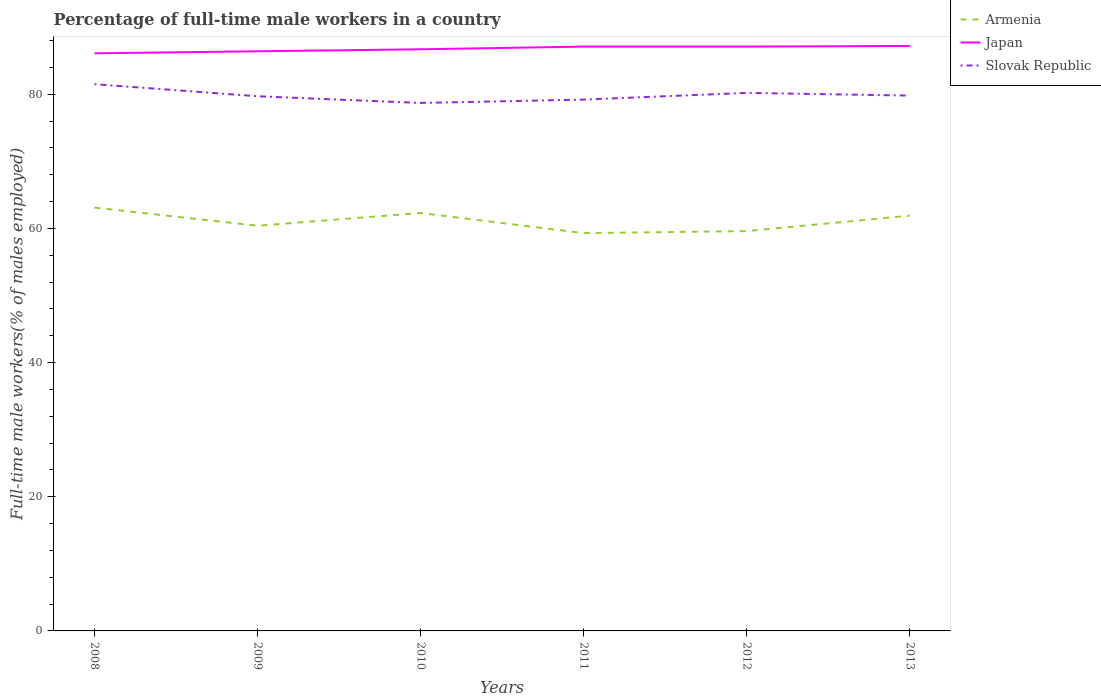Across all years, what is the maximum percentage of full-time male workers in Armenia?
Provide a succinct answer. 59.3. In which year was the percentage of full-time male workers in Slovak Republic maximum?
Give a very brief answer. 2010. What is the total percentage of full-time male workers in Japan in the graph?
Your answer should be very brief. -1.1. What is the difference between the highest and the second highest percentage of full-time male workers in Slovak Republic?
Your answer should be compact. 2.8. Is the percentage of full-time male workers in Japan strictly greater than the percentage of full-time male workers in Armenia over the years?
Provide a succinct answer. No. How many years are there in the graph?
Your answer should be very brief. 6. Where does the legend appear in the graph?
Give a very brief answer. Top right. What is the title of the graph?
Provide a short and direct response. Percentage of full-time male workers in a country. What is the label or title of the Y-axis?
Give a very brief answer. Full-time male workers(% of males employed). What is the Full-time male workers(% of males employed) in Armenia in 2008?
Keep it short and to the point. 63.1. What is the Full-time male workers(% of males employed) in Japan in 2008?
Provide a succinct answer. 86.1. What is the Full-time male workers(% of males employed) of Slovak Republic in 2008?
Your response must be concise. 81.5. What is the Full-time male workers(% of males employed) in Armenia in 2009?
Offer a terse response. 60.4. What is the Full-time male workers(% of males employed) in Japan in 2009?
Offer a terse response. 86.4. What is the Full-time male workers(% of males employed) of Slovak Republic in 2009?
Give a very brief answer. 79.7. What is the Full-time male workers(% of males employed) in Armenia in 2010?
Keep it short and to the point. 62.3. What is the Full-time male workers(% of males employed) of Japan in 2010?
Ensure brevity in your answer.  86.7. What is the Full-time male workers(% of males employed) of Slovak Republic in 2010?
Keep it short and to the point. 78.7. What is the Full-time male workers(% of males employed) of Armenia in 2011?
Make the answer very short. 59.3. What is the Full-time male workers(% of males employed) in Japan in 2011?
Your response must be concise. 87.1. What is the Full-time male workers(% of males employed) in Slovak Republic in 2011?
Provide a short and direct response. 79.2. What is the Full-time male workers(% of males employed) in Armenia in 2012?
Provide a succinct answer. 59.6. What is the Full-time male workers(% of males employed) of Japan in 2012?
Ensure brevity in your answer.  87.1. What is the Full-time male workers(% of males employed) in Slovak Republic in 2012?
Keep it short and to the point. 80.2. What is the Full-time male workers(% of males employed) in Armenia in 2013?
Your response must be concise. 61.9. What is the Full-time male workers(% of males employed) of Japan in 2013?
Your answer should be very brief. 87.2. What is the Full-time male workers(% of males employed) in Slovak Republic in 2013?
Ensure brevity in your answer.  79.8. Across all years, what is the maximum Full-time male workers(% of males employed) of Armenia?
Your answer should be very brief. 63.1. Across all years, what is the maximum Full-time male workers(% of males employed) of Japan?
Offer a very short reply. 87.2. Across all years, what is the maximum Full-time male workers(% of males employed) in Slovak Republic?
Ensure brevity in your answer.  81.5. Across all years, what is the minimum Full-time male workers(% of males employed) in Armenia?
Ensure brevity in your answer.  59.3. Across all years, what is the minimum Full-time male workers(% of males employed) in Japan?
Keep it short and to the point. 86.1. Across all years, what is the minimum Full-time male workers(% of males employed) of Slovak Republic?
Make the answer very short. 78.7. What is the total Full-time male workers(% of males employed) in Armenia in the graph?
Your answer should be compact. 366.6. What is the total Full-time male workers(% of males employed) in Japan in the graph?
Your answer should be compact. 520.6. What is the total Full-time male workers(% of males employed) in Slovak Republic in the graph?
Your response must be concise. 479.1. What is the difference between the Full-time male workers(% of males employed) of Slovak Republic in 2008 and that in 2009?
Give a very brief answer. 1.8. What is the difference between the Full-time male workers(% of males employed) of Armenia in 2008 and that in 2010?
Your answer should be compact. 0.8. What is the difference between the Full-time male workers(% of males employed) in Slovak Republic in 2008 and that in 2010?
Provide a succinct answer. 2.8. What is the difference between the Full-time male workers(% of males employed) in Armenia in 2008 and that in 2011?
Provide a succinct answer. 3.8. What is the difference between the Full-time male workers(% of males employed) in Japan in 2008 and that in 2011?
Your response must be concise. -1. What is the difference between the Full-time male workers(% of males employed) of Slovak Republic in 2008 and that in 2011?
Give a very brief answer. 2.3. What is the difference between the Full-time male workers(% of males employed) in Japan in 2008 and that in 2013?
Give a very brief answer. -1.1. What is the difference between the Full-time male workers(% of males employed) of Armenia in 2009 and that in 2010?
Your answer should be very brief. -1.9. What is the difference between the Full-time male workers(% of males employed) of Slovak Republic in 2009 and that in 2010?
Keep it short and to the point. 1. What is the difference between the Full-time male workers(% of males employed) of Slovak Republic in 2009 and that in 2011?
Keep it short and to the point. 0.5. What is the difference between the Full-time male workers(% of males employed) of Armenia in 2009 and that in 2012?
Provide a short and direct response. 0.8. What is the difference between the Full-time male workers(% of males employed) of Armenia in 2009 and that in 2013?
Provide a short and direct response. -1.5. What is the difference between the Full-time male workers(% of males employed) of Japan in 2009 and that in 2013?
Your answer should be compact. -0.8. What is the difference between the Full-time male workers(% of males employed) in Slovak Republic in 2009 and that in 2013?
Give a very brief answer. -0.1. What is the difference between the Full-time male workers(% of males employed) in Japan in 2010 and that in 2011?
Your answer should be very brief. -0.4. What is the difference between the Full-time male workers(% of males employed) of Japan in 2010 and that in 2012?
Give a very brief answer. -0.4. What is the difference between the Full-time male workers(% of males employed) in Slovak Republic in 2010 and that in 2012?
Keep it short and to the point. -1.5. What is the difference between the Full-time male workers(% of males employed) in Armenia in 2011 and that in 2012?
Provide a succinct answer. -0.3. What is the difference between the Full-time male workers(% of males employed) in Japan in 2011 and that in 2012?
Your answer should be compact. 0. What is the difference between the Full-time male workers(% of males employed) in Japan in 2012 and that in 2013?
Offer a terse response. -0.1. What is the difference between the Full-time male workers(% of males employed) in Armenia in 2008 and the Full-time male workers(% of males employed) in Japan in 2009?
Offer a very short reply. -23.3. What is the difference between the Full-time male workers(% of males employed) of Armenia in 2008 and the Full-time male workers(% of males employed) of Slovak Republic in 2009?
Give a very brief answer. -16.6. What is the difference between the Full-time male workers(% of males employed) of Armenia in 2008 and the Full-time male workers(% of males employed) of Japan in 2010?
Give a very brief answer. -23.6. What is the difference between the Full-time male workers(% of males employed) in Armenia in 2008 and the Full-time male workers(% of males employed) in Slovak Republic in 2010?
Your response must be concise. -15.6. What is the difference between the Full-time male workers(% of males employed) in Armenia in 2008 and the Full-time male workers(% of males employed) in Slovak Republic in 2011?
Your response must be concise. -16.1. What is the difference between the Full-time male workers(% of males employed) in Armenia in 2008 and the Full-time male workers(% of males employed) in Japan in 2012?
Keep it short and to the point. -24. What is the difference between the Full-time male workers(% of males employed) in Armenia in 2008 and the Full-time male workers(% of males employed) in Slovak Republic in 2012?
Your answer should be very brief. -17.1. What is the difference between the Full-time male workers(% of males employed) in Japan in 2008 and the Full-time male workers(% of males employed) in Slovak Republic in 2012?
Provide a succinct answer. 5.9. What is the difference between the Full-time male workers(% of males employed) of Armenia in 2008 and the Full-time male workers(% of males employed) of Japan in 2013?
Offer a very short reply. -24.1. What is the difference between the Full-time male workers(% of males employed) of Armenia in 2008 and the Full-time male workers(% of males employed) of Slovak Republic in 2013?
Your response must be concise. -16.7. What is the difference between the Full-time male workers(% of males employed) in Armenia in 2009 and the Full-time male workers(% of males employed) in Japan in 2010?
Give a very brief answer. -26.3. What is the difference between the Full-time male workers(% of males employed) in Armenia in 2009 and the Full-time male workers(% of males employed) in Slovak Republic in 2010?
Make the answer very short. -18.3. What is the difference between the Full-time male workers(% of males employed) of Armenia in 2009 and the Full-time male workers(% of males employed) of Japan in 2011?
Offer a terse response. -26.7. What is the difference between the Full-time male workers(% of males employed) of Armenia in 2009 and the Full-time male workers(% of males employed) of Slovak Republic in 2011?
Your answer should be very brief. -18.8. What is the difference between the Full-time male workers(% of males employed) of Armenia in 2009 and the Full-time male workers(% of males employed) of Japan in 2012?
Give a very brief answer. -26.7. What is the difference between the Full-time male workers(% of males employed) of Armenia in 2009 and the Full-time male workers(% of males employed) of Slovak Republic in 2012?
Your answer should be very brief. -19.8. What is the difference between the Full-time male workers(% of males employed) of Armenia in 2009 and the Full-time male workers(% of males employed) of Japan in 2013?
Provide a short and direct response. -26.8. What is the difference between the Full-time male workers(% of males employed) in Armenia in 2009 and the Full-time male workers(% of males employed) in Slovak Republic in 2013?
Give a very brief answer. -19.4. What is the difference between the Full-time male workers(% of males employed) in Japan in 2009 and the Full-time male workers(% of males employed) in Slovak Republic in 2013?
Make the answer very short. 6.6. What is the difference between the Full-time male workers(% of males employed) of Armenia in 2010 and the Full-time male workers(% of males employed) of Japan in 2011?
Your answer should be compact. -24.8. What is the difference between the Full-time male workers(% of males employed) in Armenia in 2010 and the Full-time male workers(% of males employed) in Slovak Republic in 2011?
Provide a short and direct response. -16.9. What is the difference between the Full-time male workers(% of males employed) of Armenia in 2010 and the Full-time male workers(% of males employed) of Japan in 2012?
Your answer should be very brief. -24.8. What is the difference between the Full-time male workers(% of males employed) in Armenia in 2010 and the Full-time male workers(% of males employed) in Slovak Republic in 2012?
Keep it short and to the point. -17.9. What is the difference between the Full-time male workers(% of males employed) in Armenia in 2010 and the Full-time male workers(% of males employed) in Japan in 2013?
Offer a very short reply. -24.9. What is the difference between the Full-time male workers(% of males employed) of Armenia in 2010 and the Full-time male workers(% of males employed) of Slovak Republic in 2013?
Ensure brevity in your answer.  -17.5. What is the difference between the Full-time male workers(% of males employed) of Armenia in 2011 and the Full-time male workers(% of males employed) of Japan in 2012?
Offer a very short reply. -27.8. What is the difference between the Full-time male workers(% of males employed) of Armenia in 2011 and the Full-time male workers(% of males employed) of Slovak Republic in 2012?
Provide a short and direct response. -20.9. What is the difference between the Full-time male workers(% of males employed) of Armenia in 2011 and the Full-time male workers(% of males employed) of Japan in 2013?
Offer a terse response. -27.9. What is the difference between the Full-time male workers(% of males employed) in Armenia in 2011 and the Full-time male workers(% of males employed) in Slovak Republic in 2013?
Provide a succinct answer. -20.5. What is the difference between the Full-time male workers(% of males employed) in Japan in 2011 and the Full-time male workers(% of males employed) in Slovak Republic in 2013?
Make the answer very short. 7.3. What is the difference between the Full-time male workers(% of males employed) of Armenia in 2012 and the Full-time male workers(% of males employed) of Japan in 2013?
Offer a terse response. -27.6. What is the difference between the Full-time male workers(% of males employed) of Armenia in 2012 and the Full-time male workers(% of males employed) of Slovak Republic in 2013?
Your answer should be compact. -20.2. What is the difference between the Full-time male workers(% of males employed) in Japan in 2012 and the Full-time male workers(% of males employed) in Slovak Republic in 2013?
Ensure brevity in your answer.  7.3. What is the average Full-time male workers(% of males employed) in Armenia per year?
Give a very brief answer. 61.1. What is the average Full-time male workers(% of males employed) in Japan per year?
Offer a very short reply. 86.77. What is the average Full-time male workers(% of males employed) of Slovak Republic per year?
Give a very brief answer. 79.85. In the year 2008, what is the difference between the Full-time male workers(% of males employed) in Armenia and Full-time male workers(% of males employed) in Slovak Republic?
Provide a short and direct response. -18.4. In the year 2009, what is the difference between the Full-time male workers(% of males employed) of Armenia and Full-time male workers(% of males employed) of Japan?
Your answer should be very brief. -26. In the year 2009, what is the difference between the Full-time male workers(% of males employed) of Armenia and Full-time male workers(% of males employed) of Slovak Republic?
Offer a very short reply. -19.3. In the year 2010, what is the difference between the Full-time male workers(% of males employed) of Armenia and Full-time male workers(% of males employed) of Japan?
Your answer should be compact. -24.4. In the year 2010, what is the difference between the Full-time male workers(% of males employed) in Armenia and Full-time male workers(% of males employed) in Slovak Republic?
Your answer should be very brief. -16.4. In the year 2011, what is the difference between the Full-time male workers(% of males employed) of Armenia and Full-time male workers(% of males employed) of Japan?
Keep it short and to the point. -27.8. In the year 2011, what is the difference between the Full-time male workers(% of males employed) of Armenia and Full-time male workers(% of males employed) of Slovak Republic?
Ensure brevity in your answer.  -19.9. In the year 2011, what is the difference between the Full-time male workers(% of males employed) of Japan and Full-time male workers(% of males employed) of Slovak Republic?
Give a very brief answer. 7.9. In the year 2012, what is the difference between the Full-time male workers(% of males employed) of Armenia and Full-time male workers(% of males employed) of Japan?
Make the answer very short. -27.5. In the year 2012, what is the difference between the Full-time male workers(% of males employed) of Armenia and Full-time male workers(% of males employed) of Slovak Republic?
Offer a terse response. -20.6. In the year 2012, what is the difference between the Full-time male workers(% of males employed) in Japan and Full-time male workers(% of males employed) in Slovak Republic?
Offer a terse response. 6.9. In the year 2013, what is the difference between the Full-time male workers(% of males employed) of Armenia and Full-time male workers(% of males employed) of Japan?
Ensure brevity in your answer.  -25.3. In the year 2013, what is the difference between the Full-time male workers(% of males employed) in Armenia and Full-time male workers(% of males employed) in Slovak Republic?
Make the answer very short. -17.9. What is the ratio of the Full-time male workers(% of males employed) in Armenia in 2008 to that in 2009?
Provide a succinct answer. 1.04. What is the ratio of the Full-time male workers(% of males employed) of Japan in 2008 to that in 2009?
Provide a succinct answer. 1. What is the ratio of the Full-time male workers(% of males employed) of Slovak Republic in 2008 to that in 2009?
Offer a terse response. 1.02. What is the ratio of the Full-time male workers(% of males employed) in Armenia in 2008 to that in 2010?
Provide a short and direct response. 1.01. What is the ratio of the Full-time male workers(% of males employed) of Japan in 2008 to that in 2010?
Your answer should be compact. 0.99. What is the ratio of the Full-time male workers(% of males employed) of Slovak Republic in 2008 to that in 2010?
Provide a succinct answer. 1.04. What is the ratio of the Full-time male workers(% of males employed) of Armenia in 2008 to that in 2011?
Your answer should be compact. 1.06. What is the ratio of the Full-time male workers(% of males employed) of Armenia in 2008 to that in 2012?
Provide a short and direct response. 1.06. What is the ratio of the Full-time male workers(% of males employed) in Japan in 2008 to that in 2012?
Provide a short and direct response. 0.99. What is the ratio of the Full-time male workers(% of males employed) in Slovak Republic in 2008 to that in 2012?
Provide a short and direct response. 1.02. What is the ratio of the Full-time male workers(% of males employed) of Armenia in 2008 to that in 2013?
Make the answer very short. 1.02. What is the ratio of the Full-time male workers(% of males employed) in Japan in 2008 to that in 2013?
Offer a terse response. 0.99. What is the ratio of the Full-time male workers(% of males employed) of Slovak Republic in 2008 to that in 2013?
Keep it short and to the point. 1.02. What is the ratio of the Full-time male workers(% of males employed) of Armenia in 2009 to that in 2010?
Your response must be concise. 0.97. What is the ratio of the Full-time male workers(% of males employed) of Slovak Republic in 2009 to that in 2010?
Provide a succinct answer. 1.01. What is the ratio of the Full-time male workers(% of males employed) of Armenia in 2009 to that in 2011?
Your response must be concise. 1.02. What is the ratio of the Full-time male workers(% of males employed) in Japan in 2009 to that in 2011?
Provide a succinct answer. 0.99. What is the ratio of the Full-time male workers(% of males employed) of Slovak Republic in 2009 to that in 2011?
Keep it short and to the point. 1.01. What is the ratio of the Full-time male workers(% of males employed) in Armenia in 2009 to that in 2012?
Ensure brevity in your answer.  1.01. What is the ratio of the Full-time male workers(% of males employed) of Armenia in 2009 to that in 2013?
Your answer should be very brief. 0.98. What is the ratio of the Full-time male workers(% of males employed) of Japan in 2009 to that in 2013?
Provide a short and direct response. 0.99. What is the ratio of the Full-time male workers(% of males employed) of Armenia in 2010 to that in 2011?
Make the answer very short. 1.05. What is the ratio of the Full-time male workers(% of males employed) of Armenia in 2010 to that in 2012?
Provide a succinct answer. 1.05. What is the ratio of the Full-time male workers(% of males employed) in Slovak Republic in 2010 to that in 2012?
Offer a terse response. 0.98. What is the ratio of the Full-time male workers(% of males employed) in Armenia in 2010 to that in 2013?
Provide a short and direct response. 1.01. What is the ratio of the Full-time male workers(% of males employed) in Japan in 2010 to that in 2013?
Keep it short and to the point. 0.99. What is the ratio of the Full-time male workers(% of males employed) in Slovak Republic in 2010 to that in 2013?
Your answer should be very brief. 0.99. What is the ratio of the Full-time male workers(% of males employed) of Slovak Republic in 2011 to that in 2012?
Provide a succinct answer. 0.99. What is the ratio of the Full-time male workers(% of males employed) in Armenia in 2011 to that in 2013?
Offer a terse response. 0.96. What is the ratio of the Full-time male workers(% of males employed) in Japan in 2011 to that in 2013?
Your answer should be very brief. 1. What is the ratio of the Full-time male workers(% of males employed) of Slovak Republic in 2011 to that in 2013?
Provide a short and direct response. 0.99. What is the ratio of the Full-time male workers(% of males employed) of Armenia in 2012 to that in 2013?
Your response must be concise. 0.96. What is the ratio of the Full-time male workers(% of males employed) in Slovak Republic in 2012 to that in 2013?
Offer a very short reply. 1. What is the difference between the highest and the second highest Full-time male workers(% of males employed) of Japan?
Your response must be concise. 0.1. What is the difference between the highest and the lowest Full-time male workers(% of males employed) of Armenia?
Offer a terse response. 3.8. What is the difference between the highest and the lowest Full-time male workers(% of males employed) in Japan?
Ensure brevity in your answer.  1.1. 